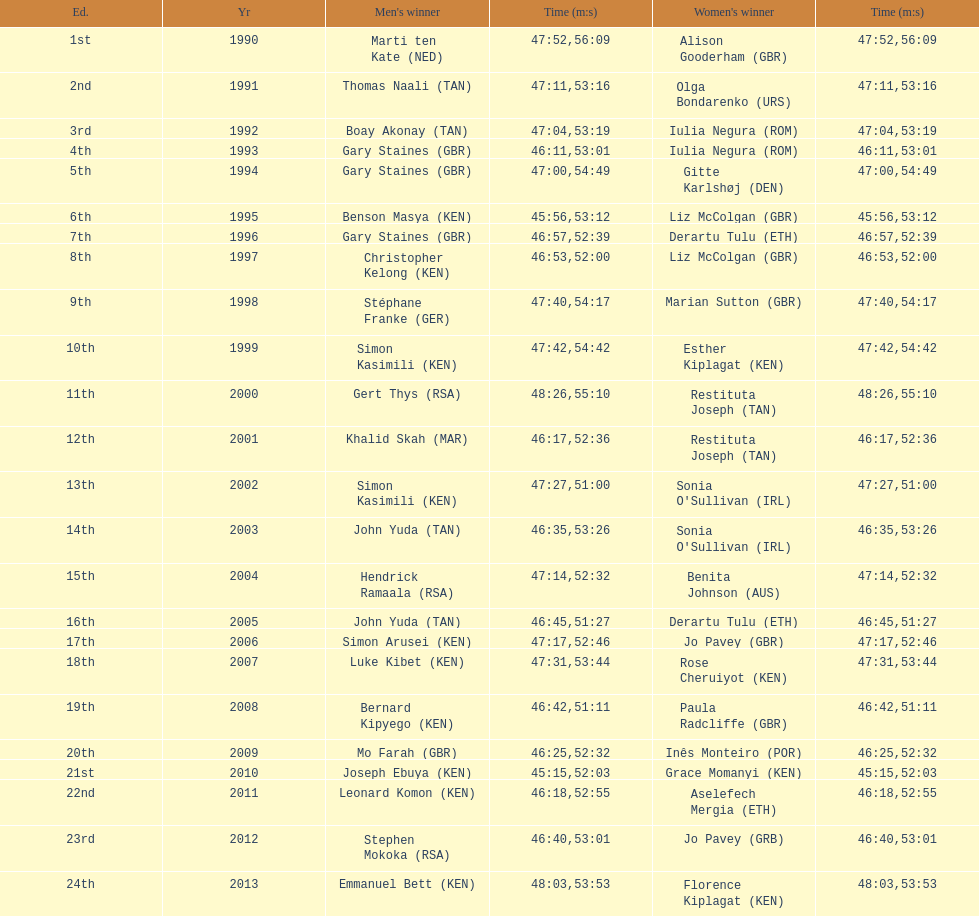Who is the male winner listed before gert thys? Simon Kasimili. 